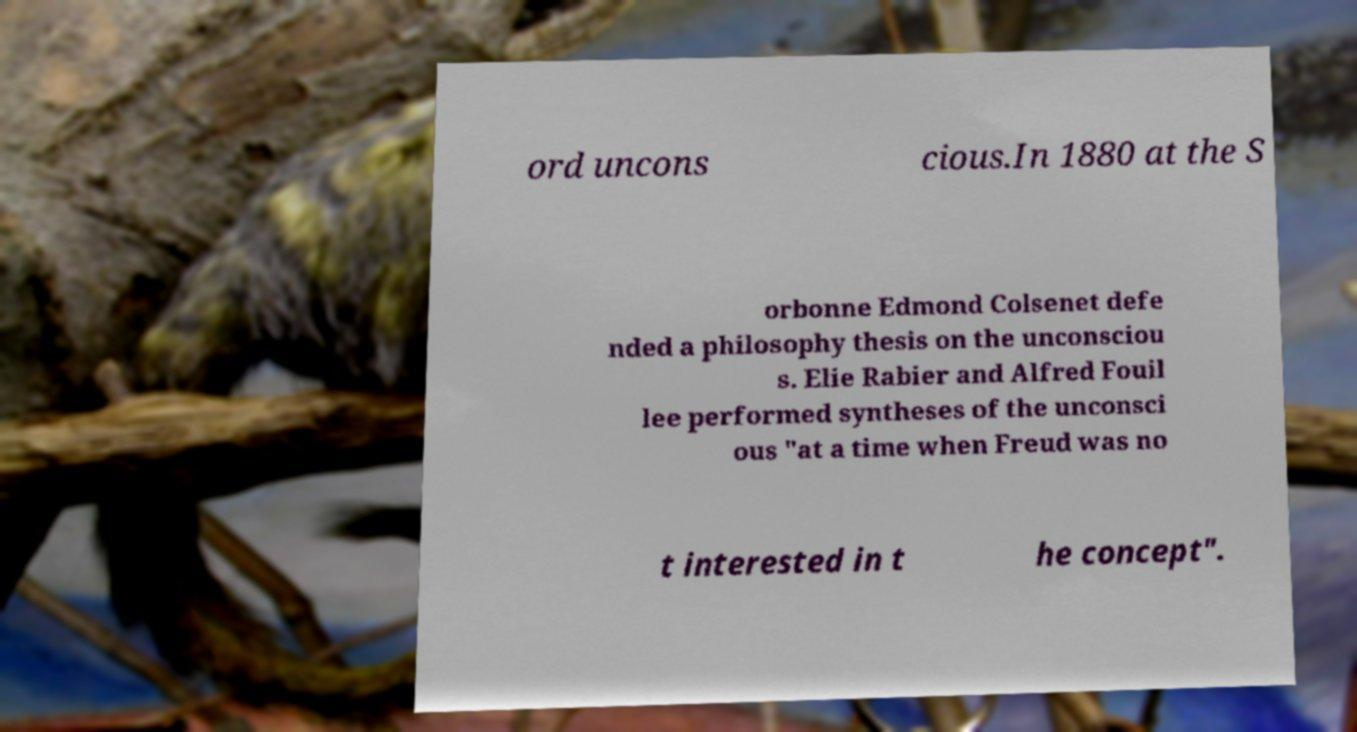Can you accurately transcribe the text from the provided image for me? ord uncons cious.In 1880 at the S orbonne Edmond Colsenet defe nded a philosophy thesis on the unconsciou s. Elie Rabier and Alfred Fouil lee performed syntheses of the unconsci ous "at a time when Freud was no t interested in t he concept". 